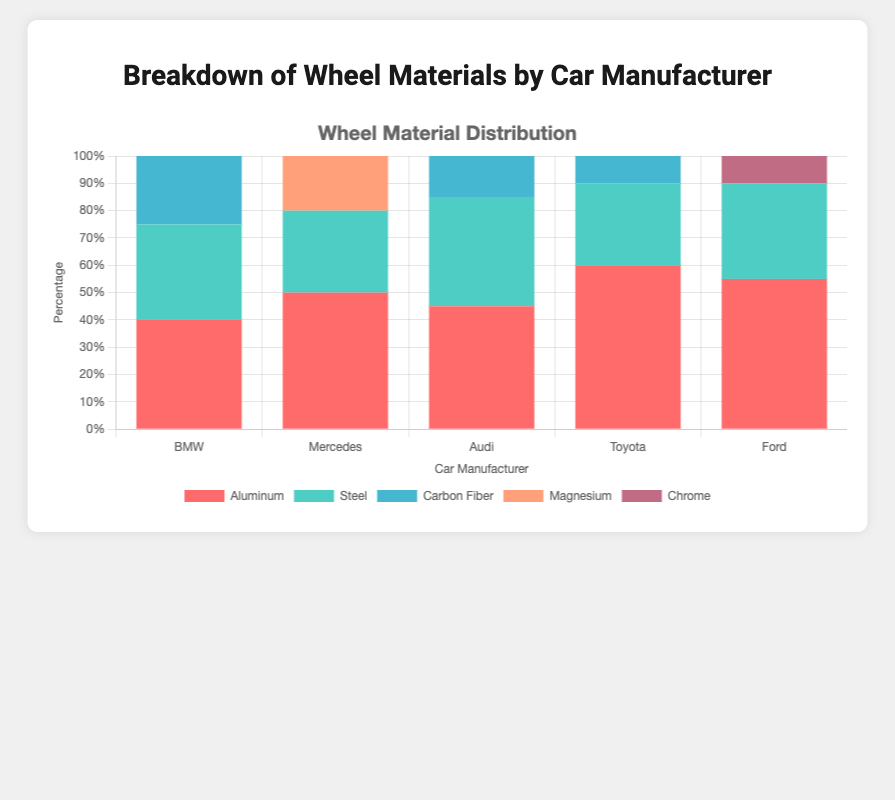What material does BMW use the least for their wheels? By looking at BMW's section in the chart, the smallest component is Carbon Fiber.
Answer: Carbon Fiber Which car manufacturer uses the highest percentage of steel for their wheels? By comparing the steel segments across all manufacturers, Toyota has the highest percentage at 30% for steel.
Answer: Toyota How much greater is the percentage of Aluminum wheels used by Toyota compared to Mercedes? The percentage of Aluminum wheels for Toyota is 60%, and for Mercedes, it is 50%. The difference is 60% - 50% = 10%.
Answer: 10% What's the total percentage of non-Aluminum wheels used by Audi? Audi uses 45% Aluminum wheels, so the non-Aluminum percentage is 100% - 45% = 55%.
Answer: 55% Which material is only used by Ford and by what percentage? Chrome is a material only used by Ford at 10%.
Answer: Chrome, 10% What is the combined percentage of Carbon Fiber wheels used by BMW and Toyota? BMW uses 25% Carbon Fiber and Toyota uses 10% Carbon Fiber. The combined percentage is 25% + 10% = 35%.
Answer: 35% Which manufacturer uses the least diverse range of wheel materials? Mercedes uses Aluminum, Steel, and Magnesium, while BMW, Audi, and Toyota use three materials each, and Ford uses four. Mercedes thus uses the least diverse range.
Answer: Mercedes Which manufacturer uses the highest percentage of Magnesium wheels? By checking the chart, only Mercedes uses Magnesium wheels at 20%.
Answer: Mercedes What is the difference in percentage between Steel wheels used by BMW and Ford? BMW uses 35% Steel wheels, and Ford uses 35% Steel wheels. So, the difference is 35% - 35% = 0%.
Answer: 0% Which material is represented by the blue segment in the chart? Observing the chart legend, the blue segment is associated with Carbon Fiber.
Answer: Carbon Fiber 